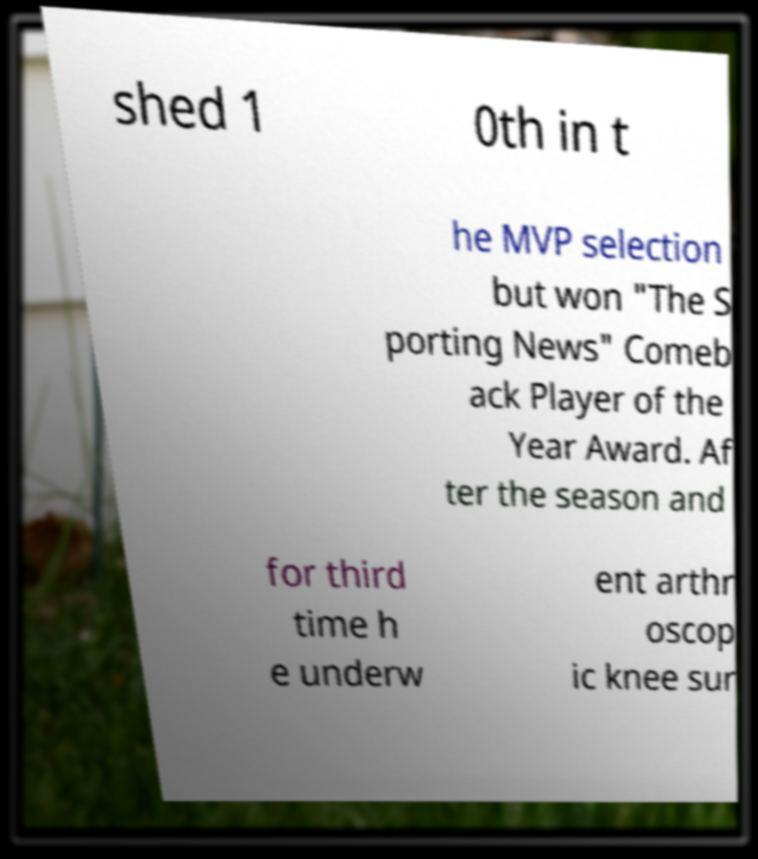For documentation purposes, I need the text within this image transcribed. Could you provide that? shed 1 0th in t he MVP selection but won "The S porting News" Comeb ack Player of the Year Award. Af ter the season and for third time h e underw ent arthr oscop ic knee sur 